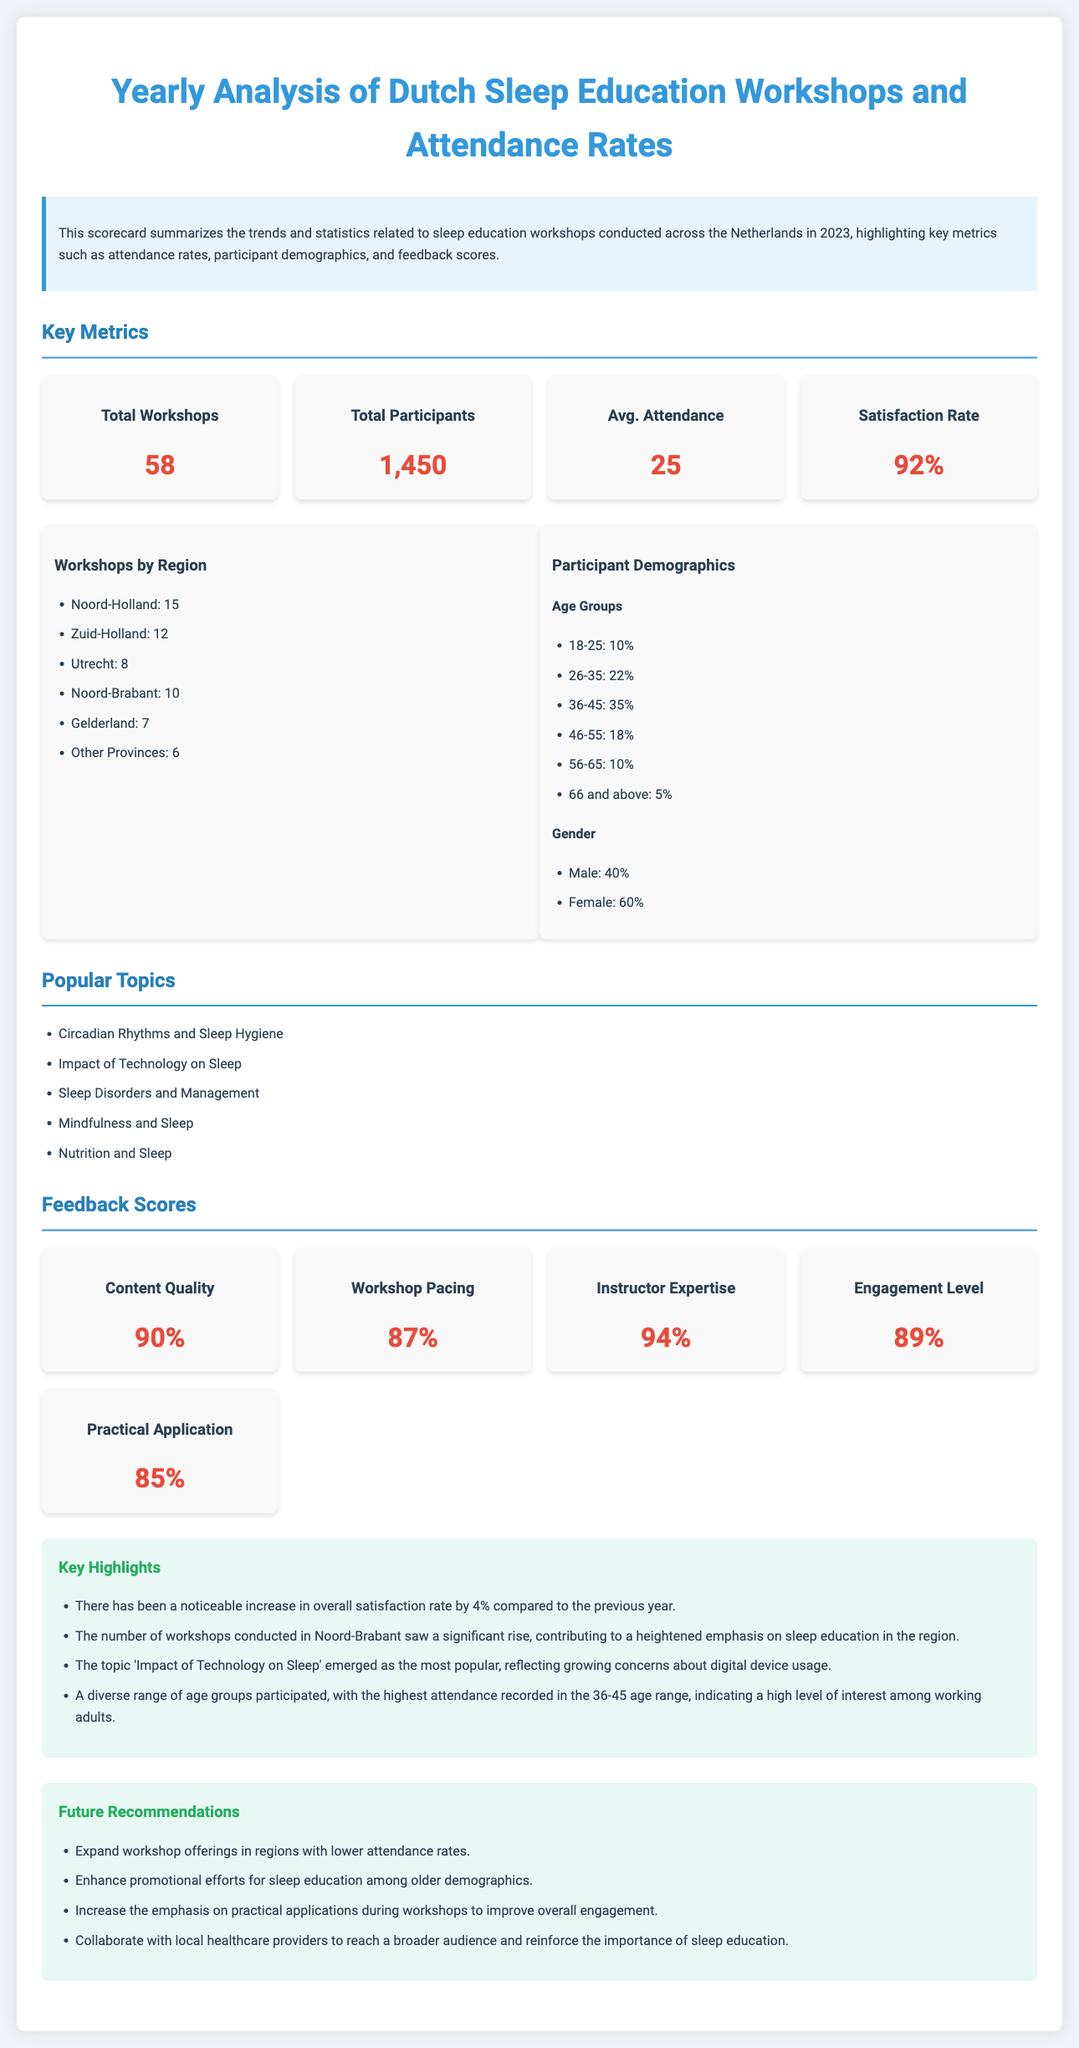What is the total number of workshops conducted? The total workshops conducted is clearly stated in the document as 58.
Answer: 58 What is the average attendance per workshop? The average attendance is calculated as total participants divided by total workshops, which is 1,450 divided by 58.
Answer: 25 What is the satisfaction rate of the participants? The document states the satisfaction rate as 92%.
Answer: 92% Which region had the highest number of workshops? The document lists Noord-Holland with 15 workshops, making it the highest region.
Answer: Noord-Holland What percentage of participants are aged 36-45? The document specifies that 35% of participants belong to the 36-45 age group.
Answer: 35% What was the most popular topic of the workshops? The document highlights "Impact of Technology on Sleep" as the most popular topic among participants.
Answer: Impact of Technology on Sleep What percentage of participants were male? The document indicates that 40% of the participants were male.
Answer: 40% What was the feedback score for instructor expertise? The document states that the feedback score for instructor expertise is 94%.
Answer: 94% What recommendation is made for future workshops? The document includes several recommendations, one of which is to expand workshop offerings in regions with lower attendance rates.
Answer: Expand workshop offerings in regions with lower attendance rates 